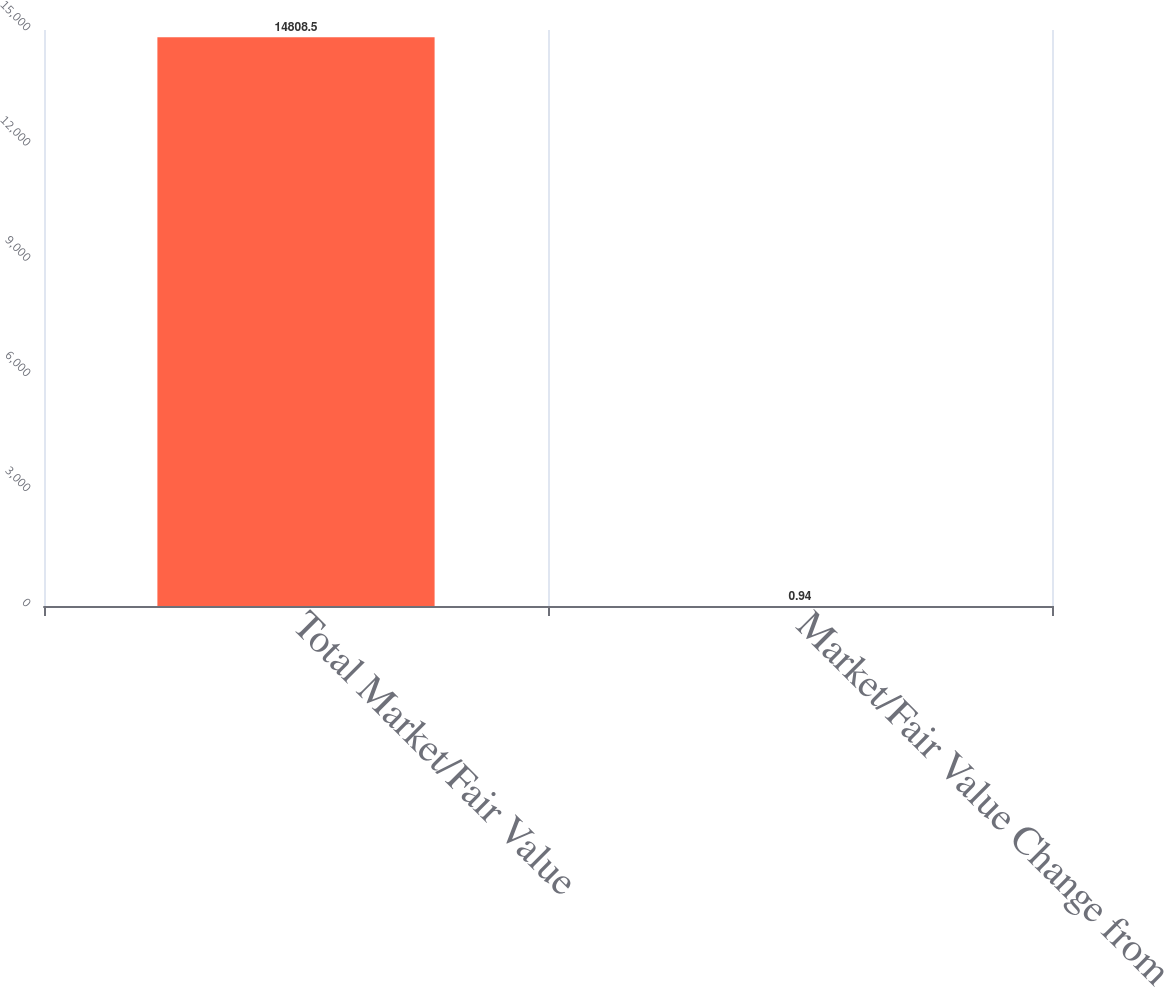<chart> <loc_0><loc_0><loc_500><loc_500><bar_chart><fcel>Total Market/Fair Value<fcel>Market/Fair Value Change from<nl><fcel>14808.5<fcel>0.94<nl></chart> 